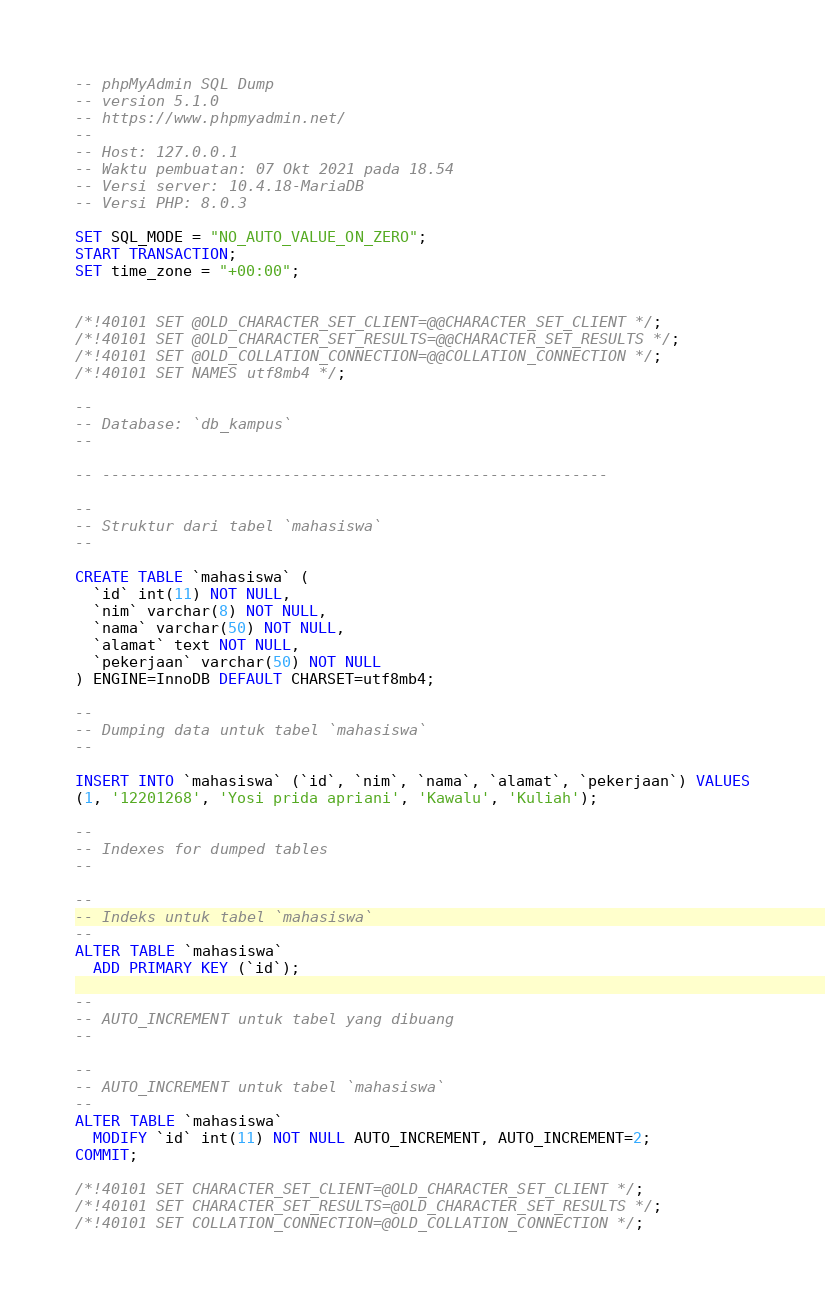Convert code to text. <code><loc_0><loc_0><loc_500><loc_500><_SQL_>-- phpMyAdmin SQL Dump
-- version 5.1.0
-- https://www.phpmyadmin.net/
--
-- Host: 127.0.0.1
-- Waktu pembuatan: 07 Okt 2021 pada 18.54
-- Versi server: 10.4.18-MariaDB
-- Versi PHP: 8.0.3

SET SQL_MODE = "NO_AUTO_VALUE_ON_ZERO";
START TRANSACTION;
SET time_zone = "+00:00";


/*!40101 SET @OLD_CHARACTER_SET_CLIENT=@@CHARACTER_SET_CLIENT */;
/*!40101 SET @OLD_CHARACTER_SET_RESULTS=@@CHARACTER_SET_RESULTS */;
/*!40101 SET @OLD_COLLATION_CONNECTION=@@COLLATION_CONNECTION */;
/*!40101 SET NAMES utf8mb4 */;

--
-- Database: `db_kampus`
--

-- --------------------------------------------------------

--
-- Struktur dari tabel `mahasiswa`
--

CREATE TABLE `mahasiswa` (
  `id` int(11) NOT NULL,
  `nim` varchar(8) NOT NULL,
  `nama` varchar(50) NOT NULL,
  `alamat` text NOT NULL,
  `pekerjaan` varchar(50) NOT NULL
) ENGINE=InnoDB DEFAULT CHARSET=utf8mb4;

--
-- Dumping data untuk tabel `mahasiswa`
--

INSERT INTO `mahasiswa` (`id`, `nim`, `nama`, `alamat`, `pekerjaan`) VALUES
(1, '12201268', 'Yosi prida apriani', 'Kawalu', 'Kuliah');

--
-- Indexes for dumped tables
--

--
-- Indeks untuk tabel `mahasiswa`
--
ALTER TABLE `mahasiswa`
  ADD PRIMARY KEY (`id`);

--
-- AUTO_INCREMENT untuk tabel yang dibuang
--

--
-- AUTO_INCREMENT untuk tabel `mahasiswa`
--
ALTER TABLE `mahasiswa`
  MODIFY `id` int(11) NOT NULL AUTO_INCREMENT, AUTO_INCREMENT=2;
COMMIT;

/*!40101 SET CHARACTER_SET_CLIENT=@OLD_CHARACTER_SET_CLIENT */;
/*!40101 SET CHARACTER_SET_RESULTS=@OLD_CHARACTER_SET_RESULTS */;
/*!40101 SET COLLATION_CONNECTION=@OLD_COLLATION_CONNECTION */;
</code> 